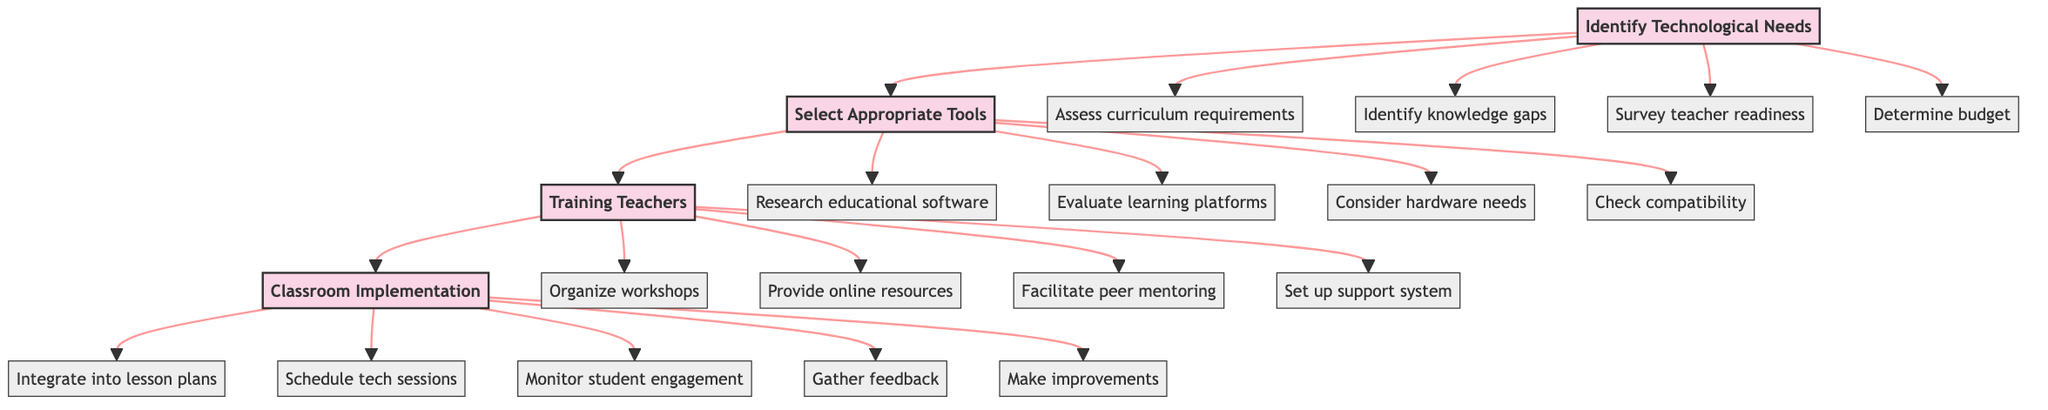What is the first stage in the integration of technology in math teaching? The diagram indicates that the first stage in the process is "Identify Technological Needs." This is the starting point from which all subsequent stages evolve.
Answer: Identify Technological Needs How many elements are associated with the "Training Teachers" stage? The "Training Teachers" stage has four associated elements listed in the diagram. Each bullet point represents a key element related to this stage of the process.
Answer: 4 What is the last step in the process shown in the diagram? The last step in the diagram, as indicated in the "Classroom Implementation" stage, is "Make iterative improvements based on feedback." This reflects the continuous nature of integrating technology in teaching.
Answer: Make iterative improvements based on feedback What links the "Select Appropriate Tools" stage to the "Training Teachers" stage? The link indicates that after selecting the appropriate tools, the next logical step is to provide training to teachers on how to implement these tools effectively in their classrooms.
Answer: Select Appropriate Tools What is one element of the "Identify Technological Needs" stage? The diagram lists multiple elements under the "Identify Technological Needs" stage. One example is "Assess current curriculum requirements," which is fundamental to understanding the technology integration needs.
Answer: Assess current curriculum requirements How are the elements within each stage organized in the diagram? In the diagram, the elements within each stage are organized as bullet points extending from their respective stage. This visual hierarchy clearly separates stages from their individual elements, making it easy to follow.
Answer: As bullet points What process follows the "Select Appropriate Tools" stage? Following the "Select Appropriate Tools" stage, the next step in the process is "Training Teachers," which emphasizes the need for teacher preparedness after selecting tools for technology integration.
Answer: Training Teachers Which stage focuses on monitoring and assessment? The "Classroom Implementation" stage focuses on monitoring and assessment, as indicated by the elements listed, which include "Monitor and assess student engagement" and "Gather feedback from teachers and students."
Answer: Classroom Implementation What does the link style in the diagram indicate? The link style in the diagram indicates the flow of processes from one stage to the next, with a specific design that highlights the connections and transitions between different stages and their elements.
Answer: Flow of processes 